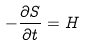Convert formula to latex. <formula><loc_0><loc_0><loc_500><loc_500>- \frac { \partial S } { \partial t } = H</formula> 